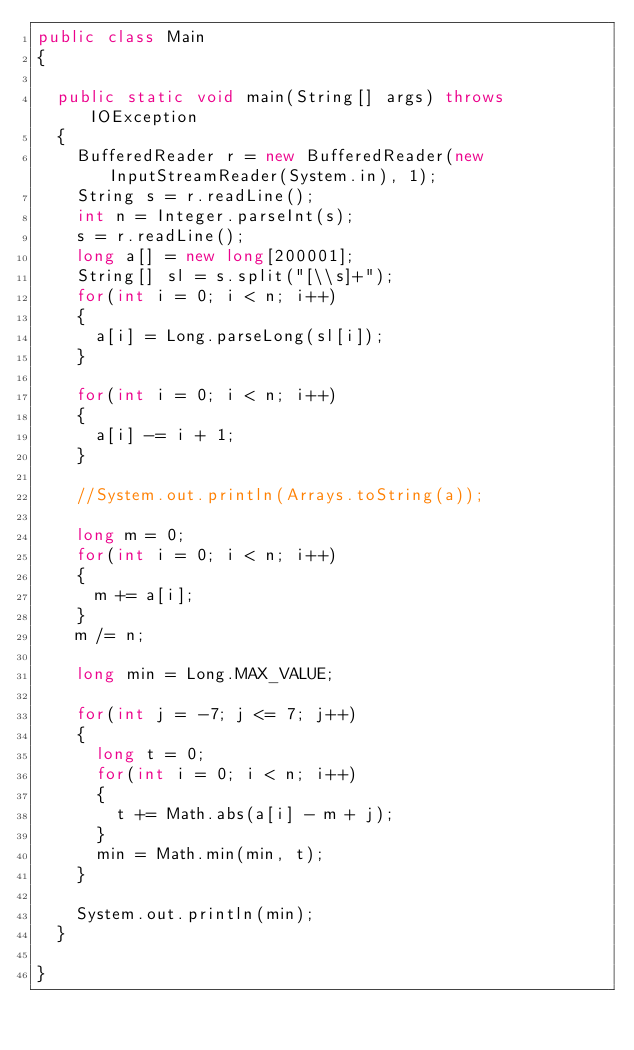Convert code to text. <code><loc_0><loc_0><loc_500><loc_500><_Java_>public class Main
{

  public static void main(String[] args) throws IOException
  {
    BufferedReader r = new BufferedReader(new InputStreamReader(System.in), 1);
    String s = r.readLine();
    int n = Integer.parseInt(s);
    s = r.readLine();
    long a[] = new long[200001];
    String[] sl = s.split("[\\s]+");
    for(int i = 0; i < n; i++)
    {
      a[i] = Long.parseLong(sl[i]);
    }

    for(int i = 0; i < n; i++)
    {
      a[i] -= i + 1;
    }

    //System.out.println(Arrays.toString(a));

    long m = 0;
    for(int i = 0; i < n; i++)
    {
      m += a[i];
    }
    m /= n;

    long min = Long.MAX_VALUE;

    for(int j = -7; j <= 7; j++)
    {
      long t = 0;
      for(int i = 0; i < n; i++)
      {
        t += Math.abs(a[i] - m + j);
      }
      min = Math.min(min, t);
    }

    System.out.println(min);
  }

}</code> 